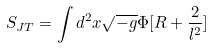Convert formula to latex. <formula><loc_0><loc_0><loc_500><loc_500>S _ { J T } = \int d ^ { 2 } x \sqrt { - g } \Phi [ R + \frac { 2 } { l ^ { 2 } } ]</formula> 